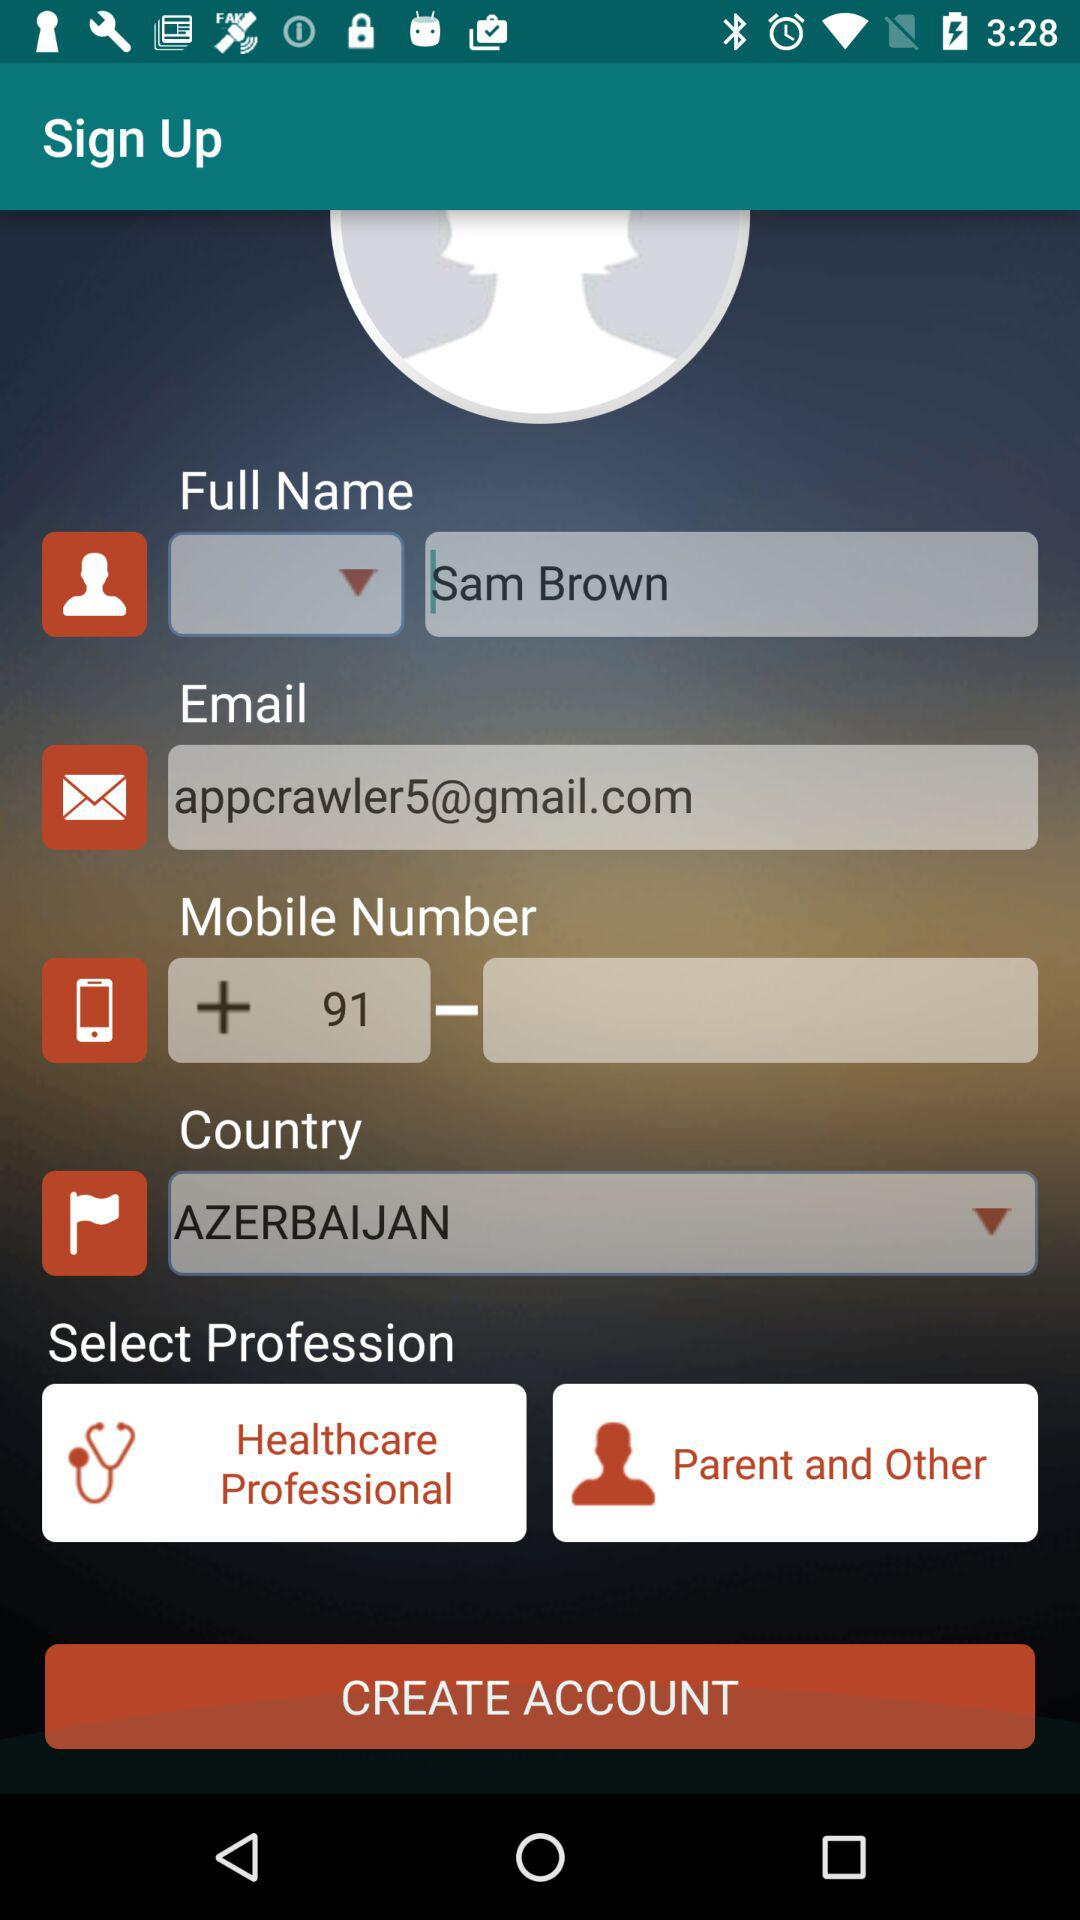What is the name? The name is Sam Brown. 